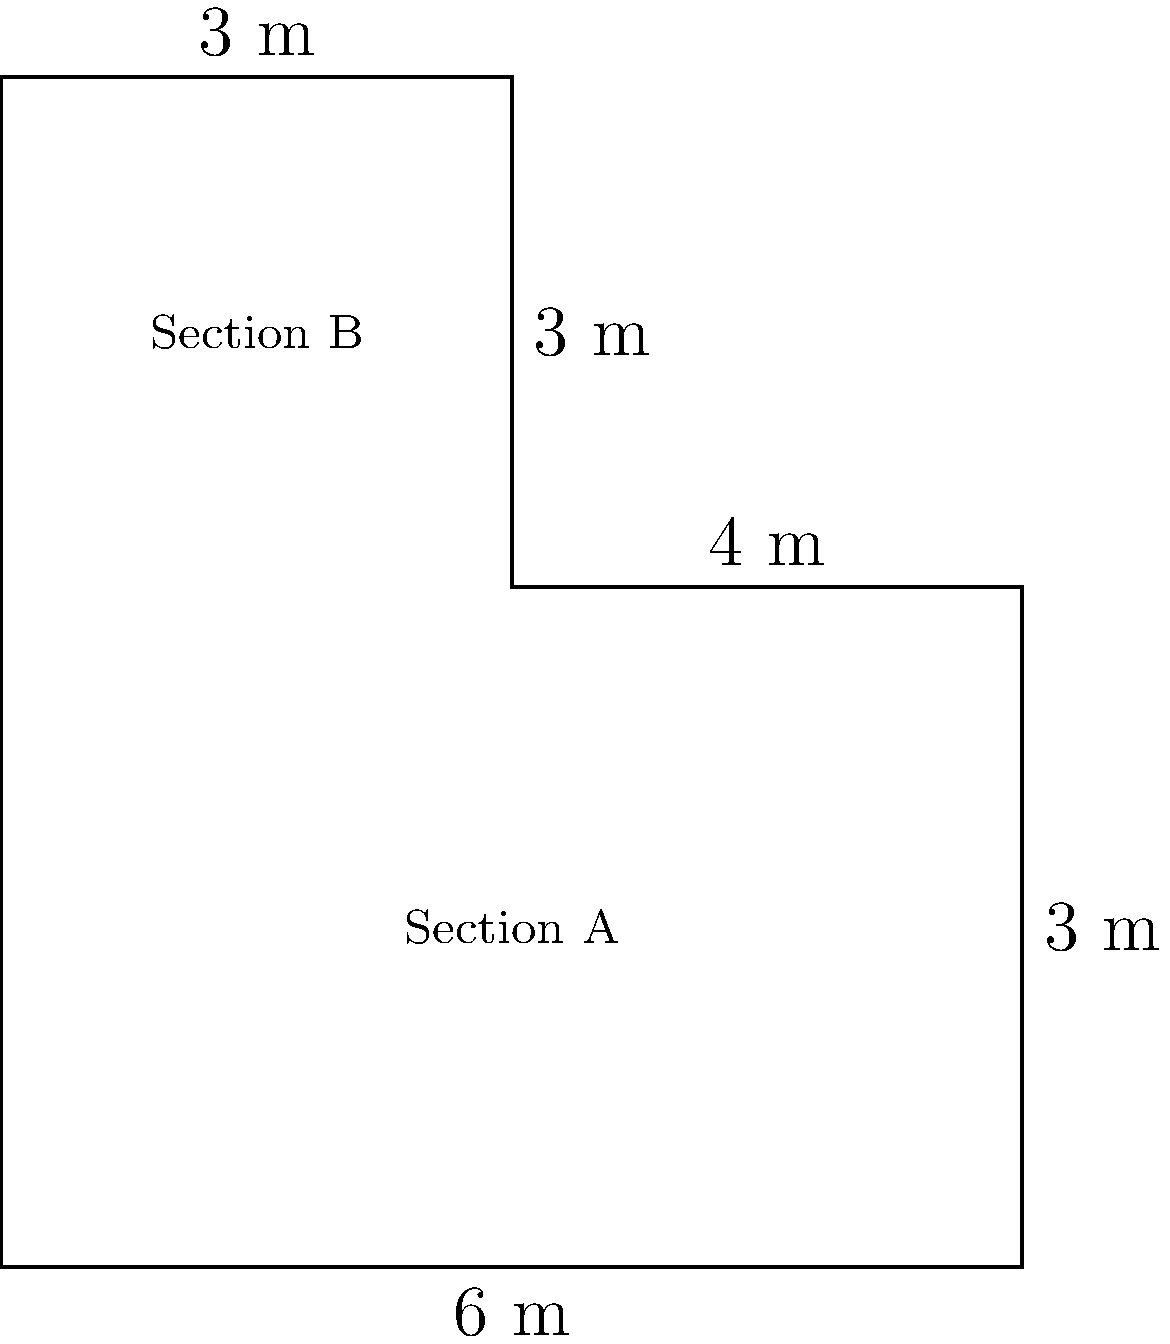As part of a bank branch renovation project, you need to determine the total area of an L-shaped office space. The office consists of two rectangular sections: Section A measures 6 m by 4 m, while Section B measures 3 m by 3 m. What is the total area of the L-shaped office space in square meters? To find the total area of the L-shaped office space, we need to calculate the areas of both sections and then add them together.

Step 1: Calculate the area of Section A
- Section A is a rectangle with length 6 m and width 4 m
- Area of Section A = length × width
- Area of Section A = $6 \text{ m} \times 4 \text{ m} = 24 \text{ m}^2$

Step 2: Calculate the area of Section B
- Section B is a rectangle with length 3 m and width 3 m
- Area of Section B = length × width
- Area of Section B = $3 \text{ m} \times 3 \text{ m} = 9 \text{ m}^2$

Step 3: Calculate the total area by adding the areas of both sections
- Total Area = Area of Section A + Area of Section B
- Total Area = $24 \text{ m}^2 + 9 \text{ m}^2 = 33 \text{ m}^2$

Therefore, the total area of the L-shaped office space is 33 square meters.
Answer: $33 \text{ m}^2$ 